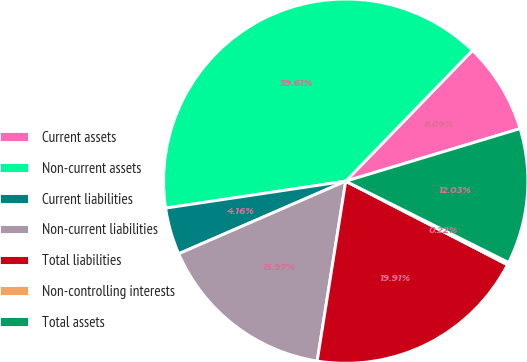Convert chart. <chart><loc_0><loc_0><loc_500><loc_500><pie_chart><fcel>Current assets<fcel>Non-current assets<fcel>Current liabilities<fcel>Non-current liabilities<fcel>Total liabilities<fcel>Non-controlling interests<fcel>Total assets<nl><fcel>8.09%<fcel>39.61%<fcel>4.16%<fcel>15.97%<fcel>19.91%<fcel>0.22%<fcel>12.03%<nl></chart> 